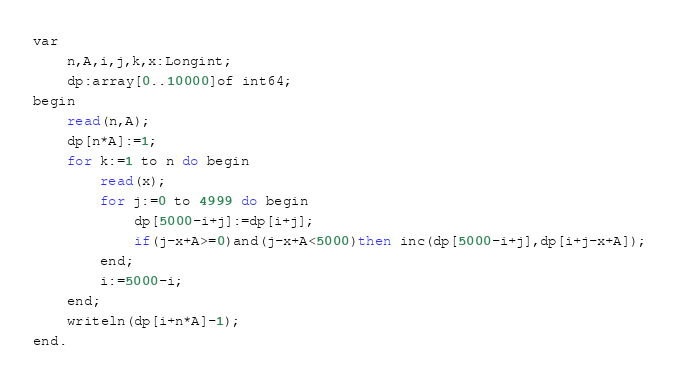<code> <loc_0><loc_0><loc_500><loc_500><_Perl_>var
	n,A,i,j,k,x:Longint;
	dp:array[0..10000]of int64;
begin
	read(n,A);
	dp[n*A]:=1;
	for k:=1 to n do begin
		read(x);
		for j:=0 to 4999 do begin
			dp[5000-i+j]:=dp[i+j];
			if(j-x+A>=0)and(j-x+A<5000)then inc(dp[5000-i+j],dp[i+j-x+A]);
		end;
		i:=5000-i;
	end;
	writeln(dp[i+n*A]-1);
end.
</code> 